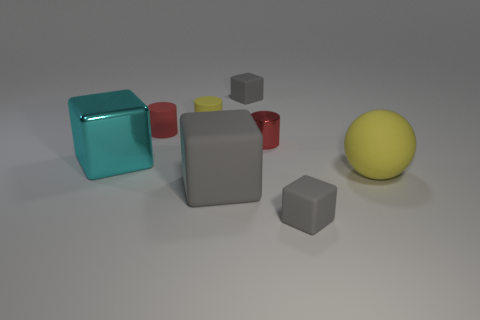What material is the big block that is to the left of the big gray rubber block in front of the cyan metallic object to the left of the yellow rubber cylinder?
Keep it short and to the point. Metal. What is the size of the cube that is both behind the yellow rubber sphere and in front of the small red rubber object?
Your answer should be very brief. Large. Do the small metal thing and the small yellow matte thing have the same shape?
Keep it short and to the point. Yes. There is a red thing that is the same material as the big cyan block; what is its shape?
Provide a succinct answer. Cylinder. What number of big objects are either red things or yellow cylinders?
Provide a short and direct response. 0. There is a small cylinder that is left of the yellow matte cylinder; are there any cyan cubes on the right side of it?
Your answer should be compact. No. Is there a tiny brown cylinder?
Your answer should be very brief. No. The ball to the right of the gray cube that is behind the big yellow rubber sphere is what color?
Your response must be concise. Yellow. There is another large object that is the same shape as the big cyan metallic thing; what material is it?
Ensure brevity in your answer.  Rubber. How many cylinders have the same size as the sphere?
Give a very brief answer. 0. 